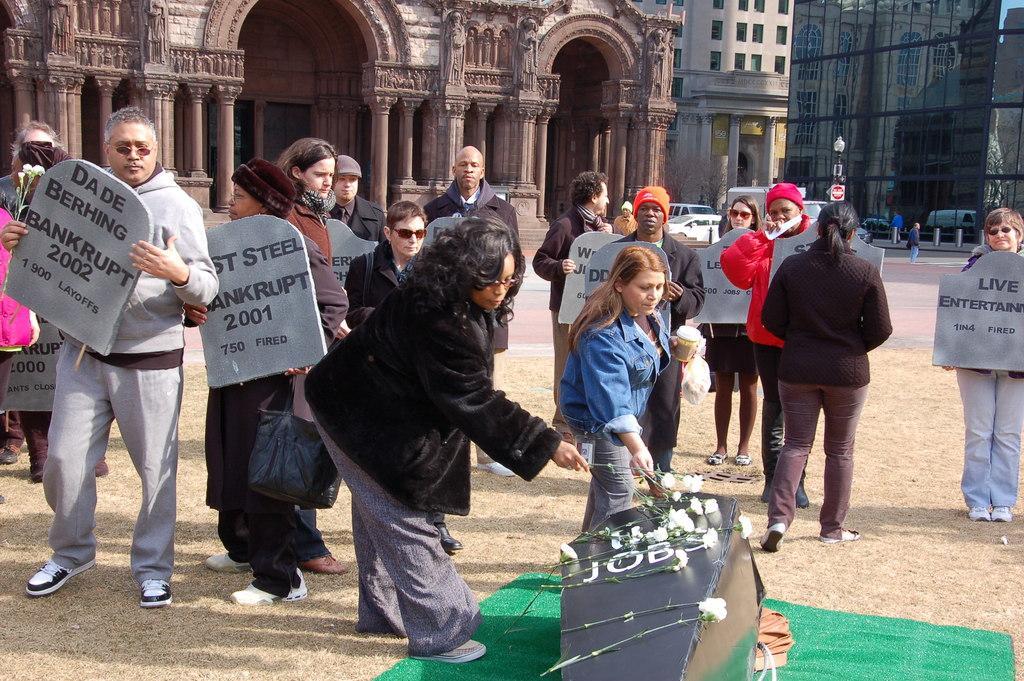Can you describe this image briefly? In this image we can see a group of people. Among them few people are holding objects. In the foreground we can see a group of flowers and an object. Behind the persons we can see a group of buildings and vehicles. 